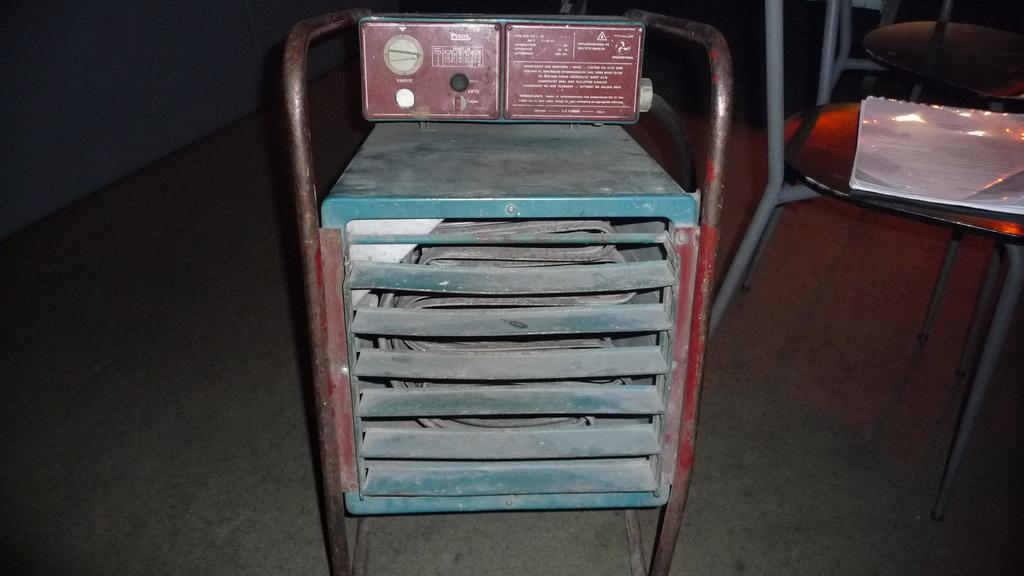What is located in the front of the image? There is a metal stand in the front of the image. What can be seen on the right side of the image? There are chairs on the right side of the image. What is placed on one of the chairs? A file is placed on one of the chairs. How would you describe the overall lighting in the image? The background of the image is dark. Can you see any cactus plants in the image? There is no cactus plant present in the image. What type of gold object is visible in the image? There is no gold object present in the image. 